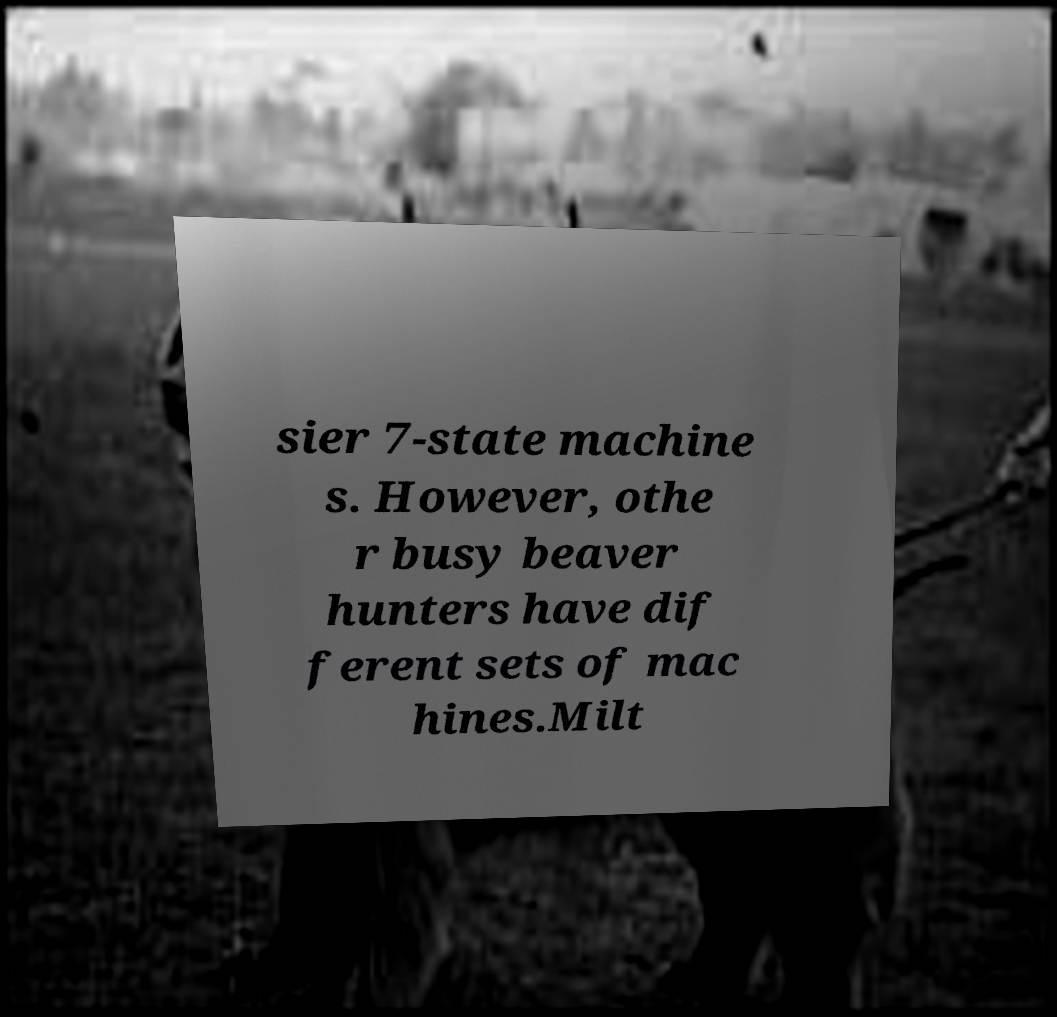Can you read and provide the text displayed in the image?This photo seems to have some interesting text. Can you extract and type it out for me? sier 7-state machine s. However, othe r busy beaver hunters have dif ferent sets of mac hines.Milt 